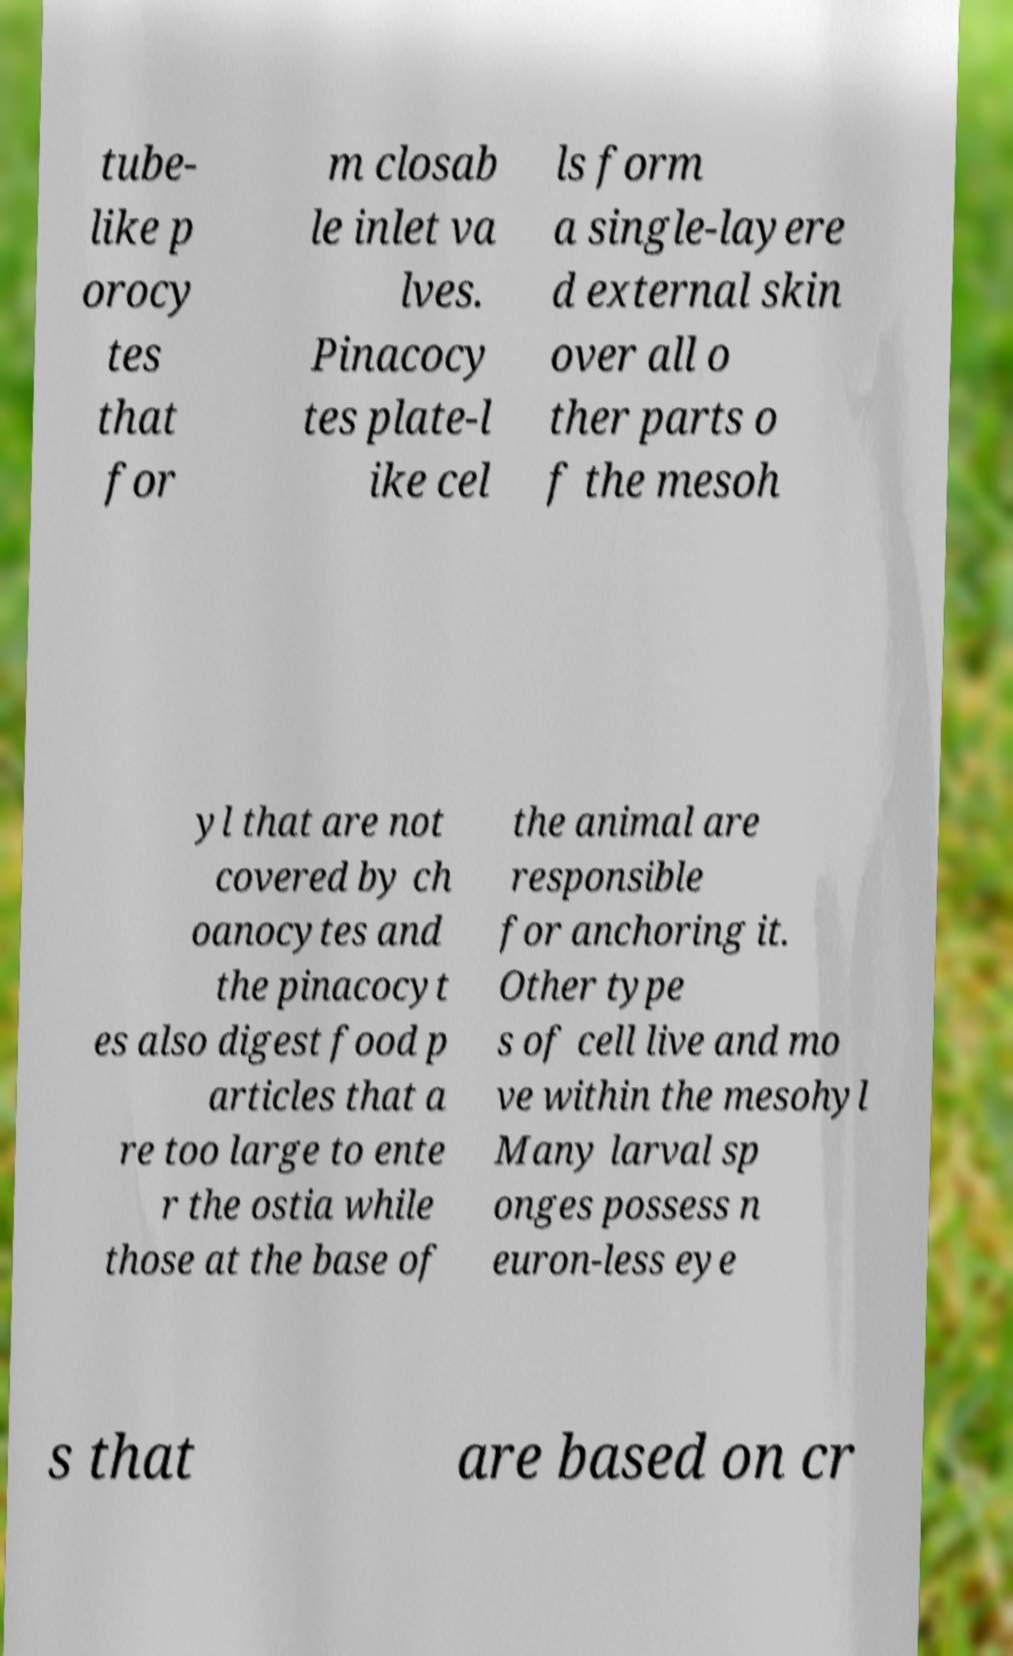Could you assist in decoding the text presented in this image and type it out clearly? tube- like p orocy tes that for m closab le inlet va lves. Pinacocy tes plate-l ike cel ls form a single-layere d external skin over all o ther parts o f the mesoh yl that are not covered by ch oanocytes and the pinacocyt es also digest food p articles that a re too large to ente r the ostia while those at the base of the animal are responsible for anchoring it. Other type s of cell live and mo ve within the mesohyl Many larval sp onges possess n euron-less eye s that are based on cr 